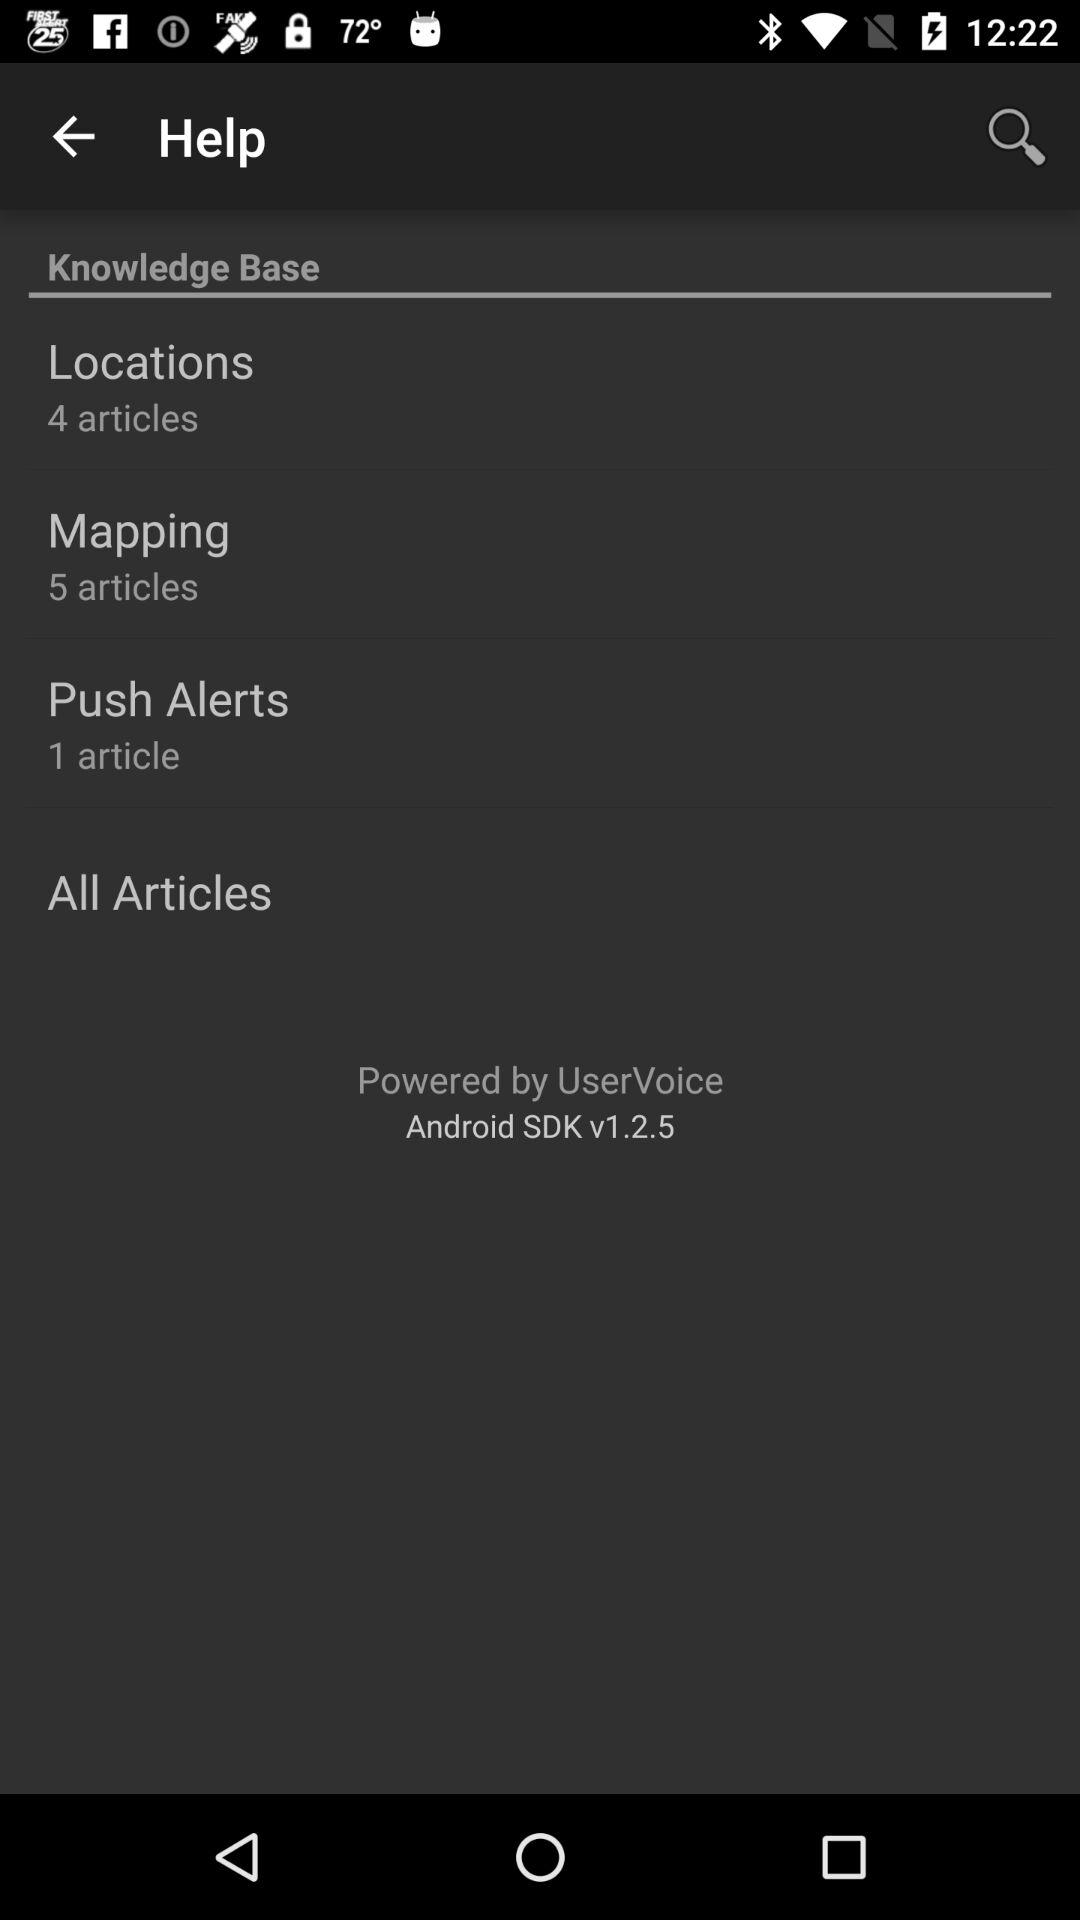How many articles are there in "Locations"? There are 4 articles in "Locations". 